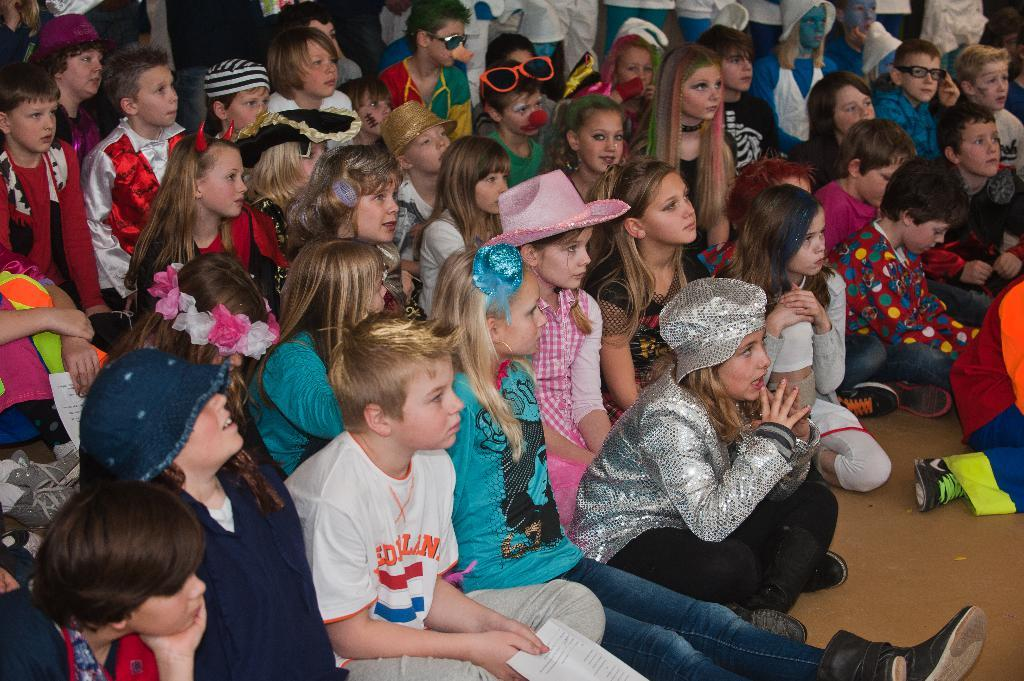What are the persons in the image doing? There are persons sitting and standing in the image. Can you describe the positions of the persons in the image? Some persons are sitting, while others are standing. How many bikes are parked next to the persons in the image? There is no mention of bikes in the image; it only features persons sitting and standing. What type of party is being held in the image? There is no indication of a party in the image; it simply shows persons sitting and standing. 